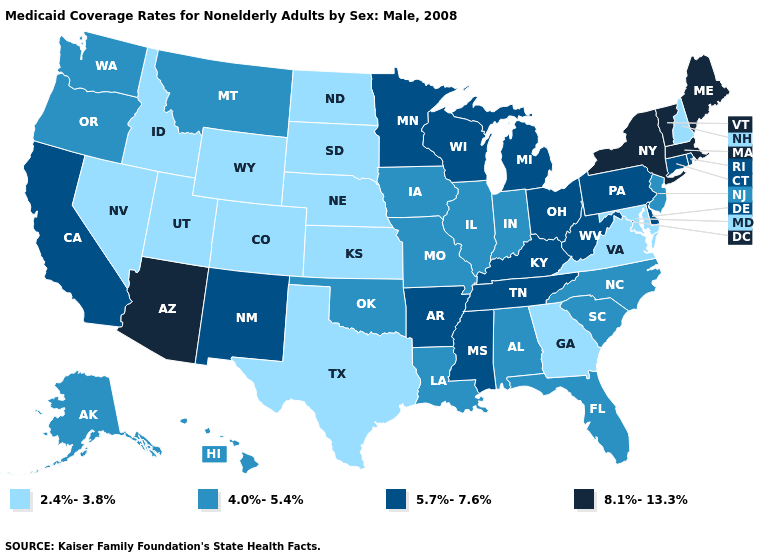Name the states that have a value in the range 2.4%-3.8%?
Be succinct. Colorado, Georgia, Idaho, Kansas, Maryland, Nebraska, Nevada, New Hampshire, North Dakota, South Dakota, Texas, Utah, Virginia, Wyoming. Is the legend a continuous bar?
Short answer required. No. Which states have the highest value in the USA?
Write a very short answer. Arizona, Maine, Massachusetts, New York, Vermont. Among the states that border Nebraska , does Colorado have the highest value?
Short answer required. No. Which states hav the highest value in the Northeast?
Keep it brief. Maine, Massachusetts, New York, Vermont. Among the states that border Indiana , does Illinois have the lowest value?
Concise answer only. Yes. What is the lowest value in the USA?
Be succinct. 2.4%-3.8%. Name the states that have a value in the range 8.1%-13.3%?
Concise answer only. Arizona, Maine, Massachusetts, New York, Vermont. Does Oklahoma have the lowest value in the South?
Answer briefly. No. Does Maryland have the same value as Georgia?
Concise answer only. Yes. Is the legend a continuous bar?
Quick response, please. No. Does Connecticut have the lowest value in the Northeast?
Write a very short answer. No. Does Washington have the lowest value in the West?
Keep it brief. No. Does the first symbol in the legend represent the smallest category?
Quick response, please. Yes. 